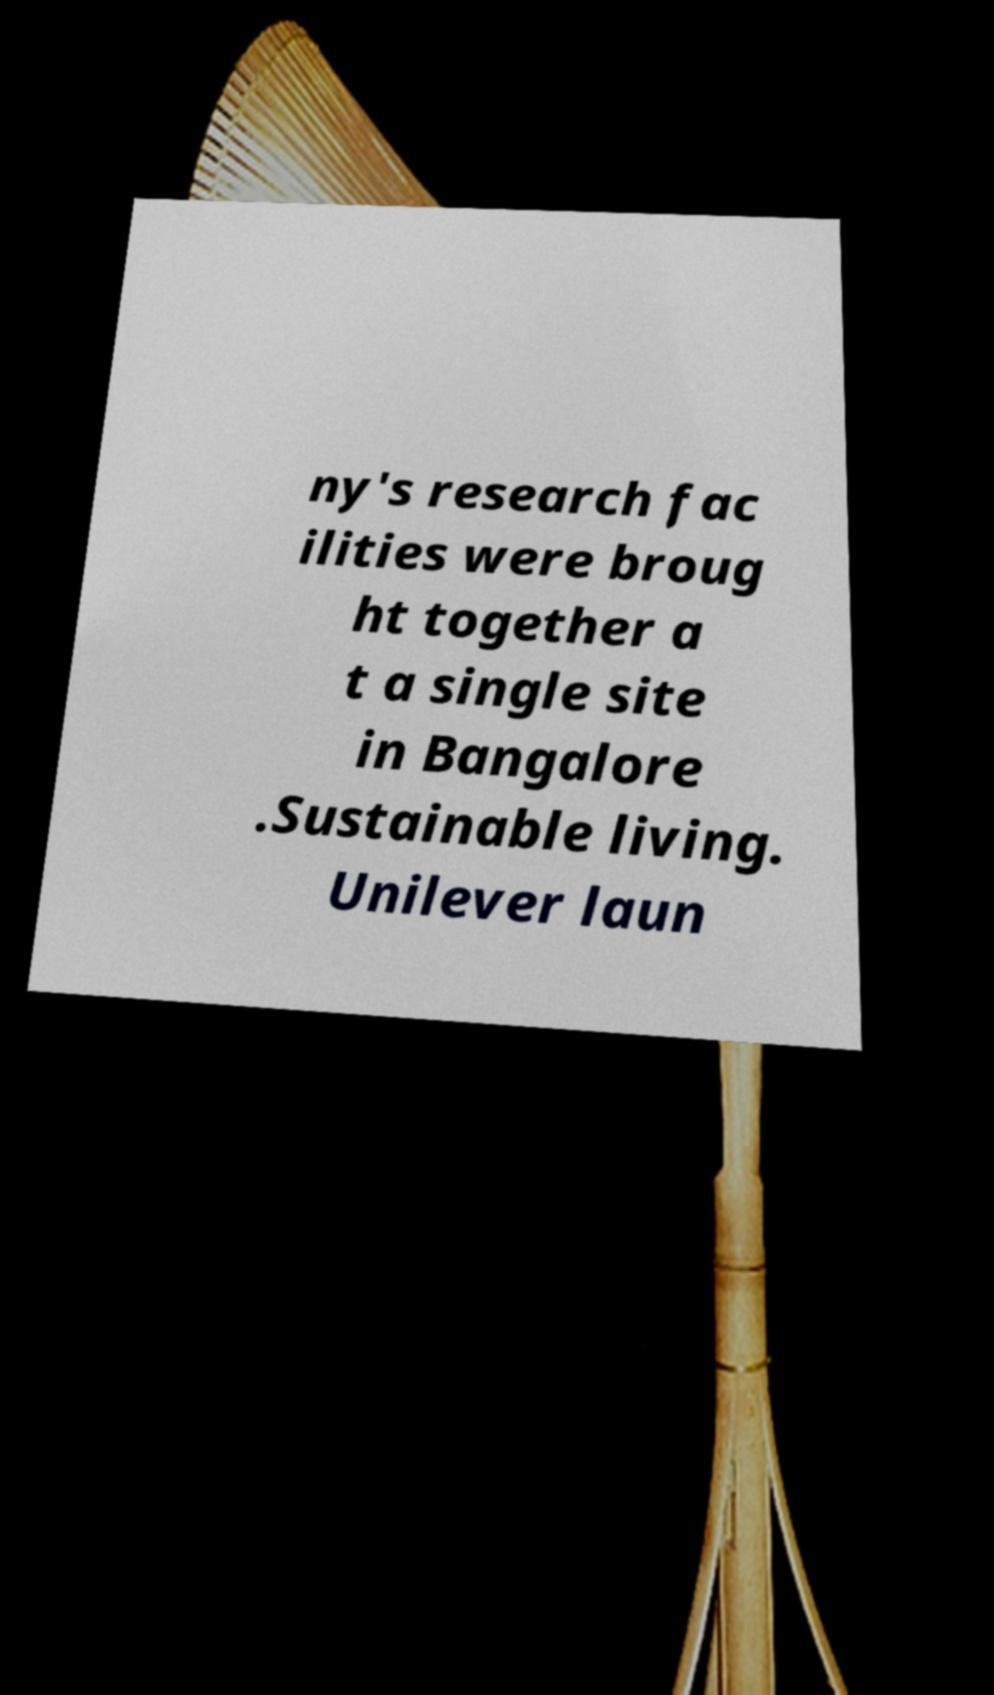Can you accurately transcribe the text from the provided image for me? ny's research fac ilities were broug ht together a t a single site in Bangalore .Sustainable living. Unilever laun 